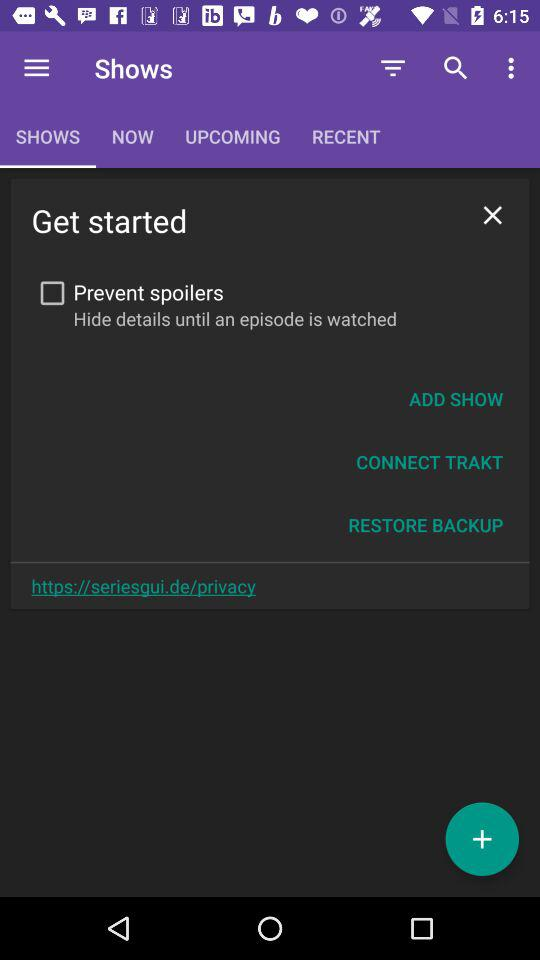What is the status of the "Prevent spoilers"? The status is "off". 